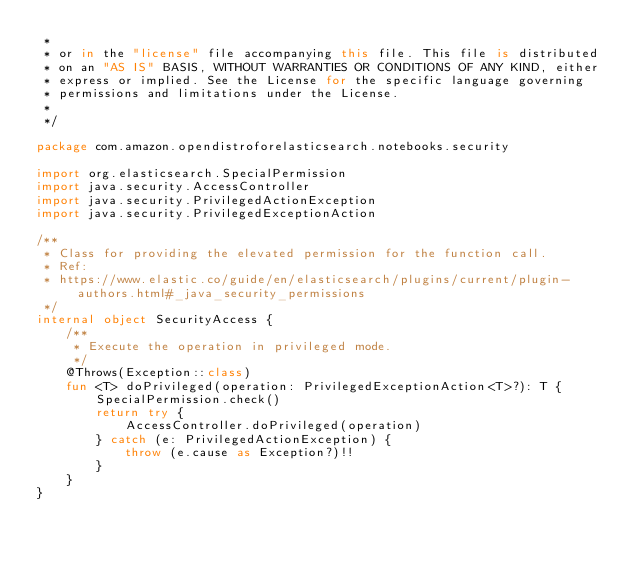<code> <loc_0><loc_0><loc_500><loc_500><_Kotlin_> *
 * or in the "license" file accompanying this file. This file is distributed
 * on an "AS IS" BASIS, WITHOUT WARRANTIES OR CONDITIONS OF ANY KIND, either
 * express or implied. See the License for the specific language governing
 * permissions and limitations under the License.
 *
 */

package com.amazon.opendistroforelasticsearch.notebooks.security

import org.elasticsearch.SpecialPermission
import java.security.AccessController
import java.security.PrivilegedActionException
import java.security.PrivilegedExceptionAction

/**
 * Class for providing the elevated permission for the function call.
 * Ref:
 * https://www.elastic.co/guide/en/elasticsearch/plugins/current/plugin-authors.html#_java_security_permissions
 */
internal object SecurityAccess {
    /**
     * Execute the operation in privileged mode.
     */
    @Throws(Exception::class)
    fun <T> doPrivileged(operation: PrivilegedExceptionAction<T>?): T {
        SpecialPermission.check()
        return try {
            AccessController.doPrivileged(operation)
        } catch (e: PrivilegedActionException) {
            throw (e.cause as Exception?)!!
        }
    }
}
</code> 